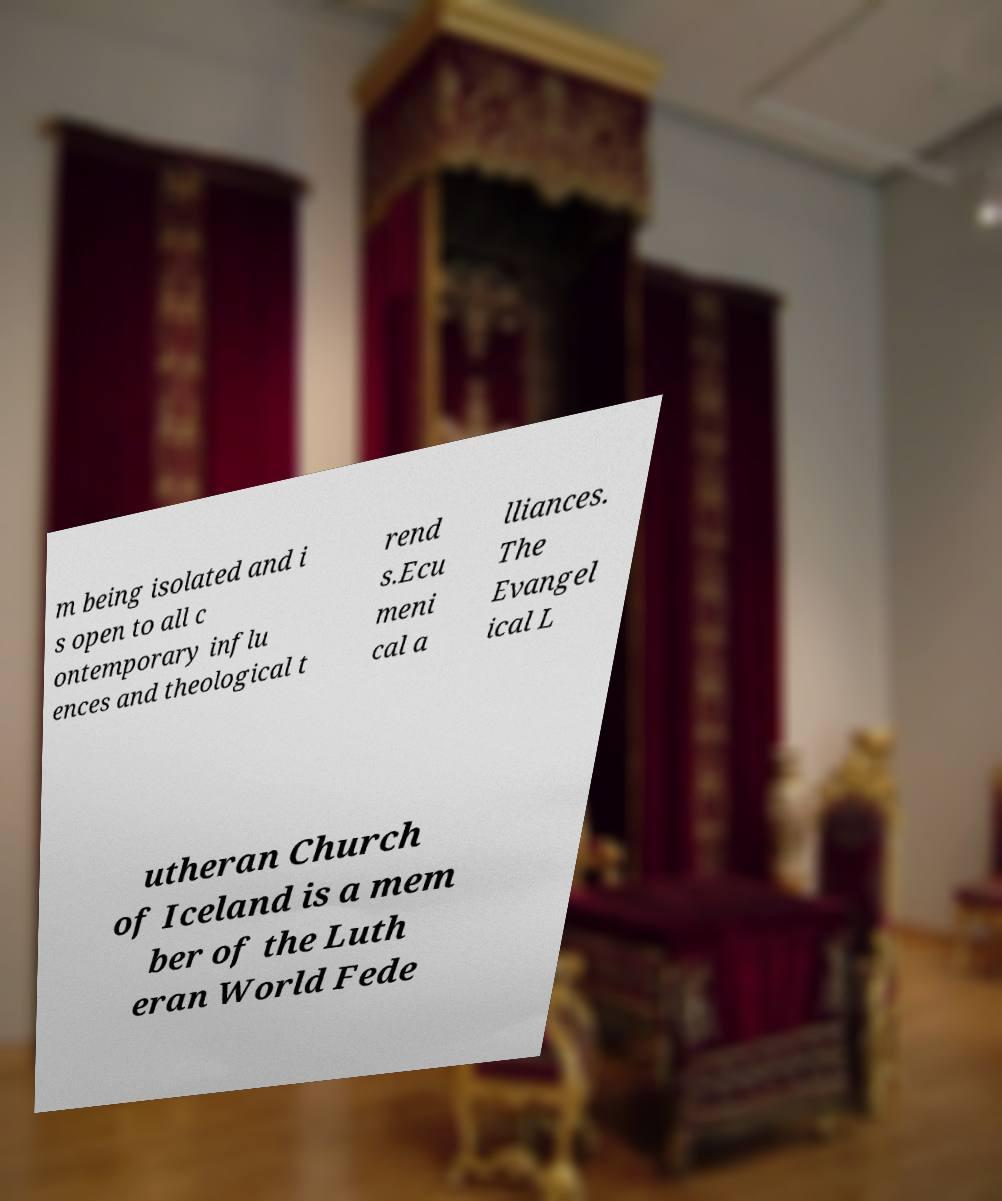Please read and relay the text visible in this image. What does it say? m being isolated and i s open to all c ontemporary influ ences and theological t rend s.Ecu meni cal a lliances. The Evangel ical L utheran Church of Iceland is a mem ber of the Luth eran World Fede 